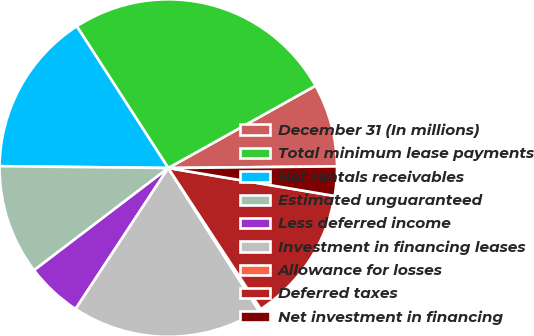<chart> <loc_0><loc_0><loc_500><loc_500><pie_chart><fcel>December 31 (In millions)<fcel>Total minimum lease payments<fcel>Net rentals receivables<fcel>Estimated unguaranteed<fcel>Less deferred income<fcel>Investment in financing leases<fcel>Allowance for losses<fcel>Deferred taxes<fcel>Net investment in financing<nl><fcel>7.96%<fcel>26.01%<fcel>15.7%<fcel>10.54%<fcel>5.38%<fcel>18.27%<fcel>0.22%<fcel>13.12%<fcel>2.8%<nl></chart> 